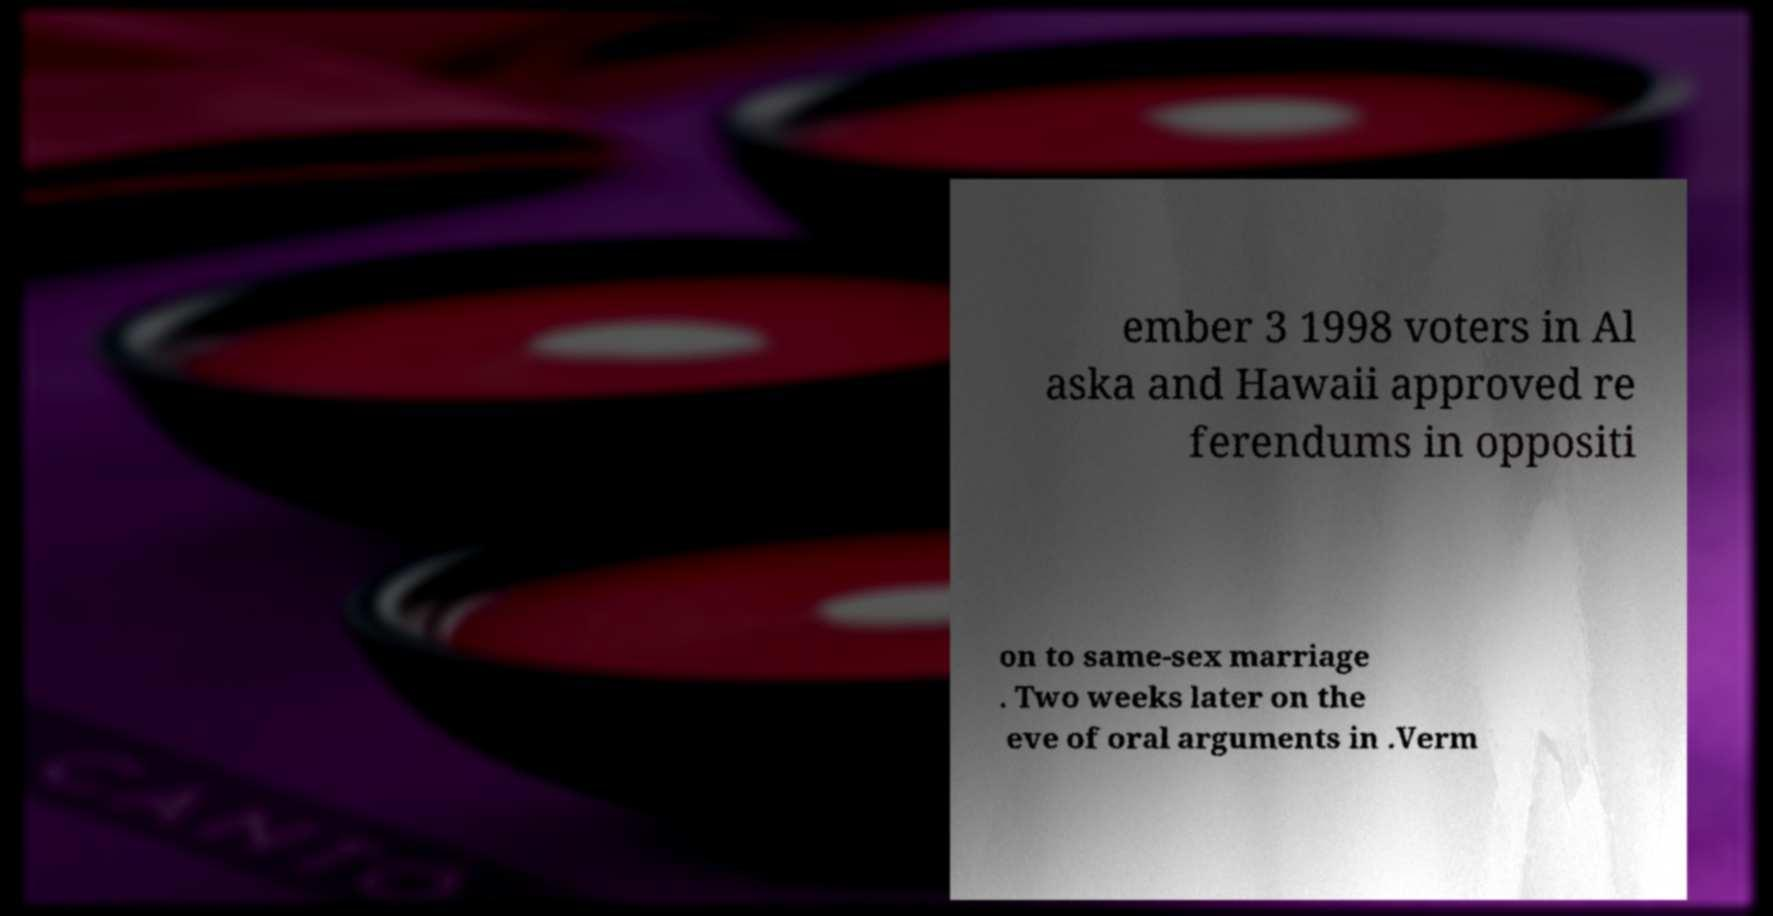Can you read and provide the text displayed in the image?This photo seems to have some interesting text. Can you extract and type it out for me? ember 3 1998 voters in Al aska and Hawaii approved re ferendums in oppositi on to same-sex marriage . Two weeks later on the eve of oral arguments in .Verm 